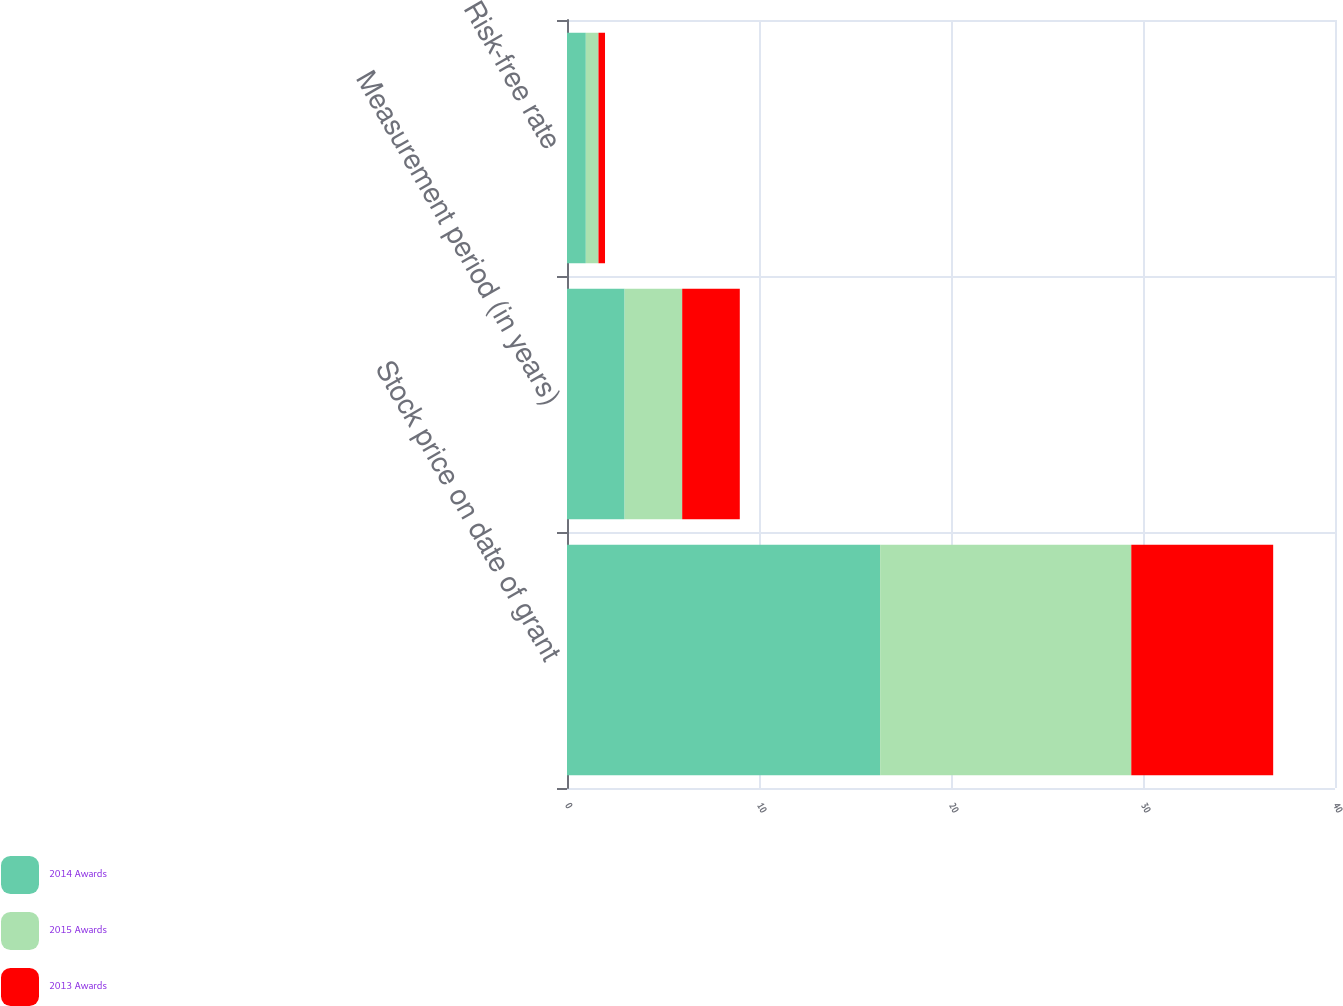Convert chart to OTSL. <chart><loc_0><loc_0><loc_500><loc_500><stacked_bar_chart><ecel><fcel>Stock price on date of grant<fcel>Measurement period (in years)<fcel>Risk-free rate<nl><fcel>2014 Awards<fcel>16.31<fcel>3<fcel>0.98<nl><fcel>2015 Awards<fcel>13.08<fcel>3<fcel>0.66<nl><fcel>2013 Awards<fcel>7.39<fcel>3<fcel>0.34<nl></chart> 